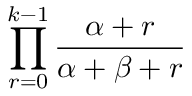Convert formula to latex. <formula><loc_0><loc_0><loc_500><loc_500>\prod _ { r = 0 } ^ { k - 1 } { \frac { \alpha + r } { \alpha + \beta + r } }</formula> 